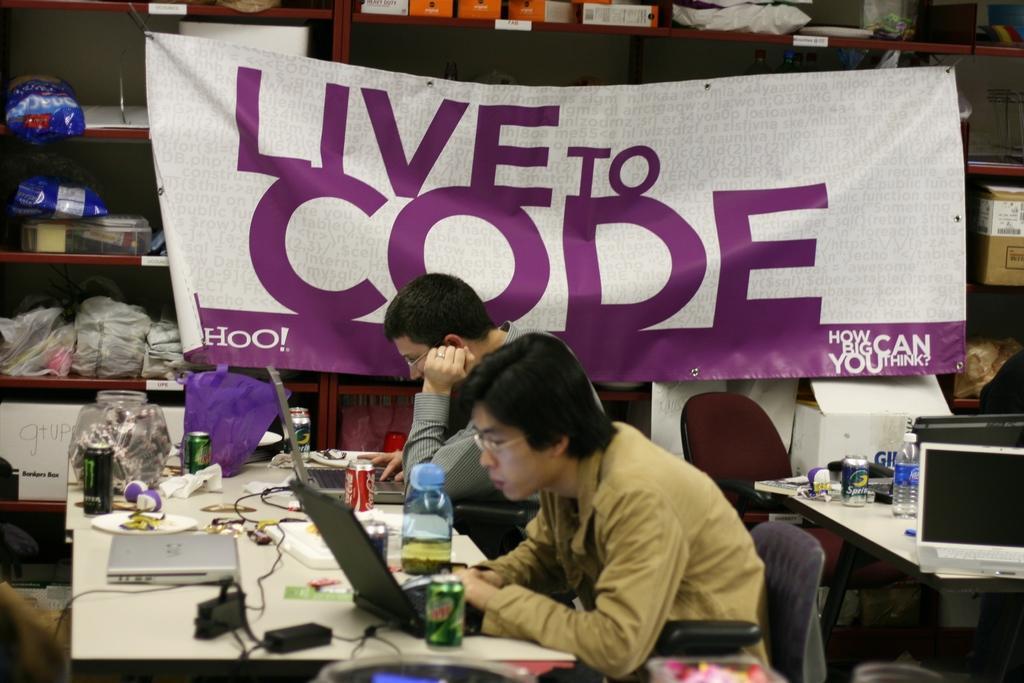Please provide a concise description of this image. In the picture I can see two men are sitting on chairs in front of a table and operating laptops. On tables I can see laptops, bottles, tin cans and some other objects. In the background I can see a banner which has something written on it and shelves which has some objects. 